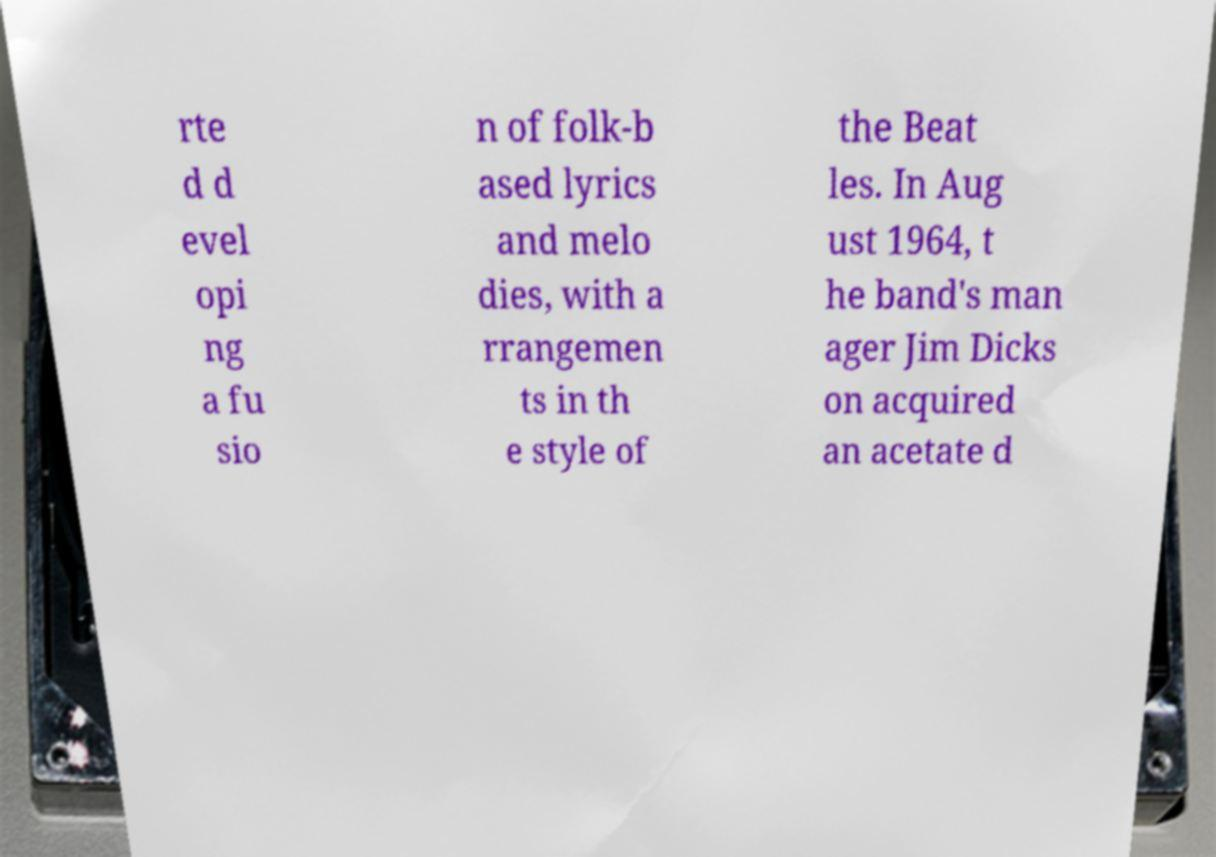There's text embedded in this image that I need extracted. Can you transcribe it verbatim? rte d d evel opi ng a fu sio n of folk-b ased lyrics and melo dies, with a rrangemen ts in th e style of the Beat les. In Aug ust 1964, t he band's man ager Jim Dicks on acquired an acetate d 